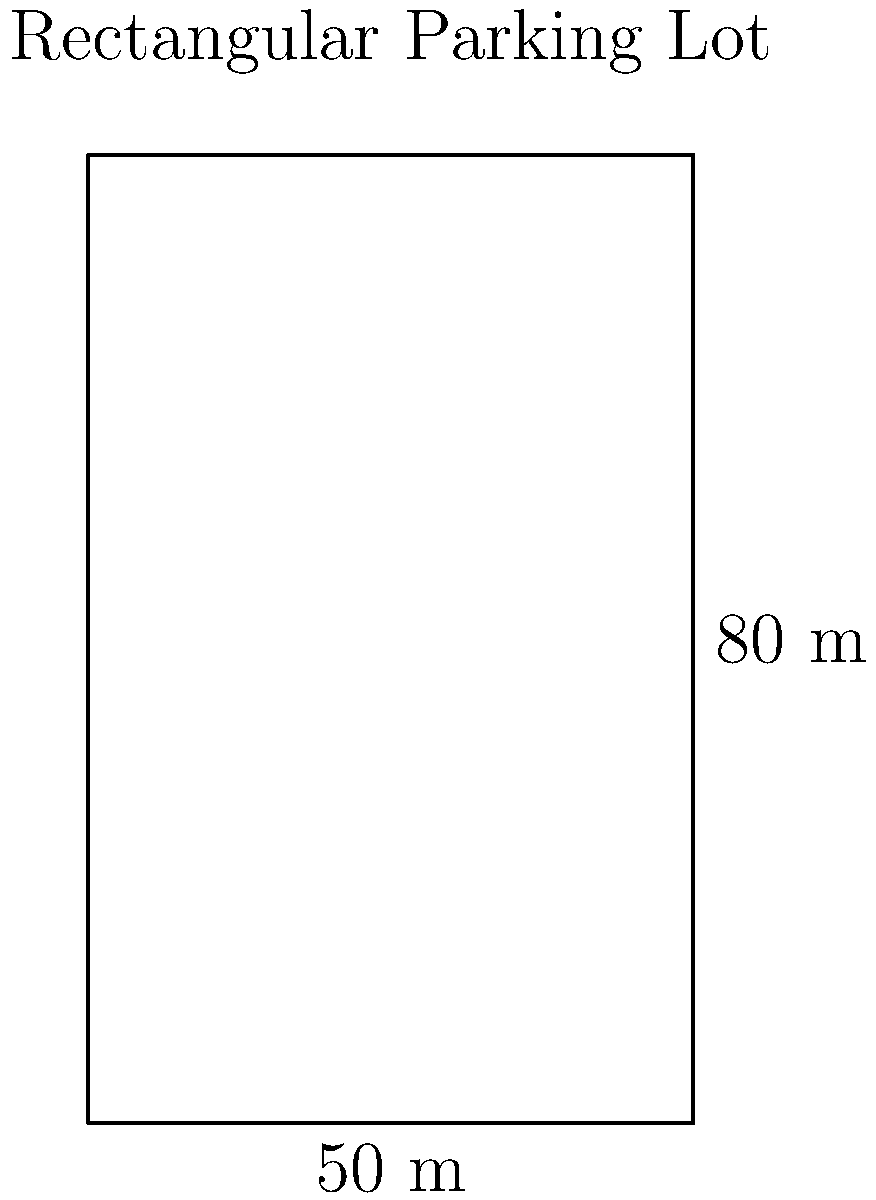A shopping mall wants to install fencing around its rectangular parking lot. The lot measures 50 meters in width and 80 meters in length. How many meters of fencing will be needed to completely enclose the parking lot? To solve this problem, we need to calculate the perimeter of the rectangular parking lot. Let's break it down step-by-step:

1. Understand the formula for perimeter of a rectangle:
   Perimeter = 2 × (length + width)

2. Identify the given dimensions:
   Width = 50 meters
   Length = 80 meters

3. Apply the formula:
   Perimeter = 2 × (80 m + 50 m)
   
4. Calculate:
   Perimeter = 2 × 130 m
   Perimeter = 260 m

Therefore, the shopping mall will need 260 meters of fencing to completely enclose the parking lot.
Answer: 260 meters 